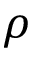Convert formula to latex. <formula><loc_0><loc_0><loc_500><loc_500>\rho</formula> 